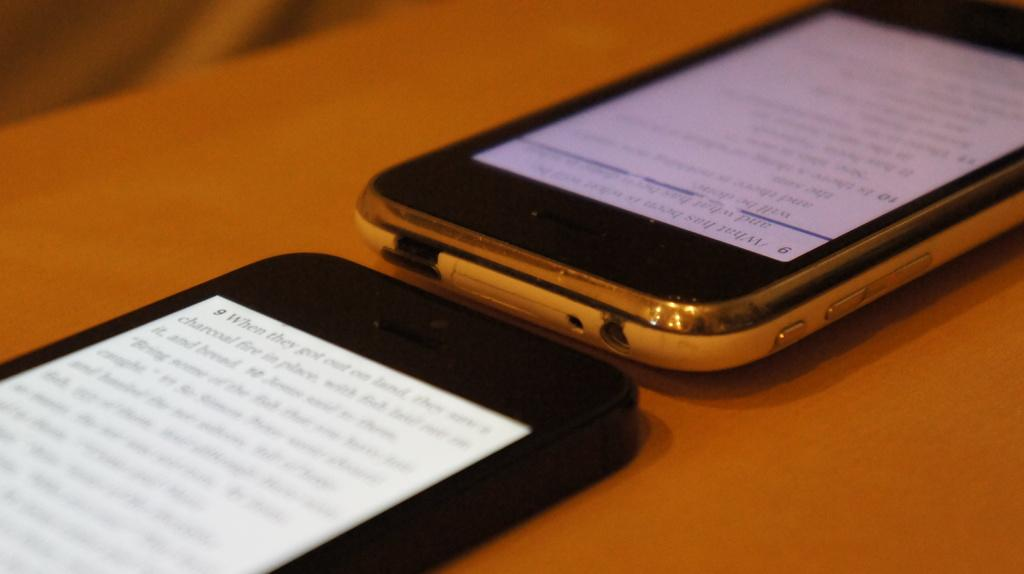What objects are present in the image? There are mobiles in the image. Where are the mobiles located? The mobiles are placed on a table. What type of body is visible in the image? There is no body present in the image; it only features mobiles on a table. Can you see a scarecrow in the image? No, there is no scarecrow present in the image. 